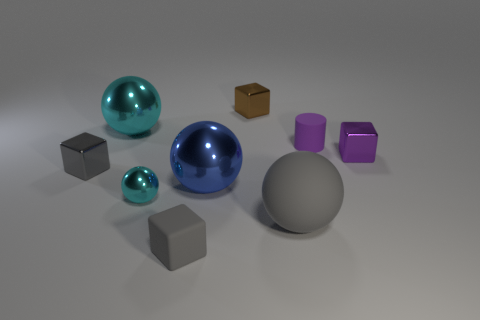Add 1 small metallic spheres. How many objects exist? 10 Subtract all cubes. How many objects are left? 5 Add 8 tiny balls. How many tiny balls exist? 9 Subtract 0 purple balls. How many objects are left? 9 Subtract all gray cubes. Subtract all big cyan shiny things. How many objects are left? 6 Add 5 tiny gray rubber blocks. How many tiny gray rubber blocks are left? 6 